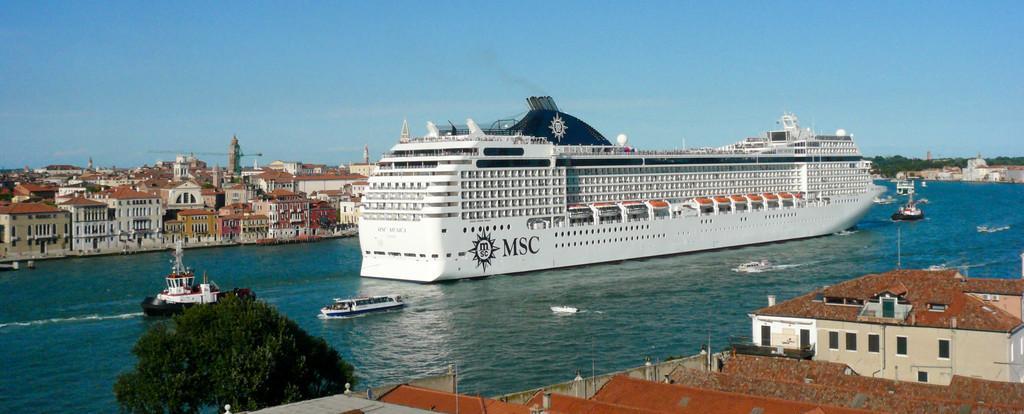Please provide a concise description of this image. In this image I can see the water, a tree, the roofs of few buildings, few boats and a huge ship on the surface of the water. In the background I can see few trees, few buildings, a crane and the sky. 